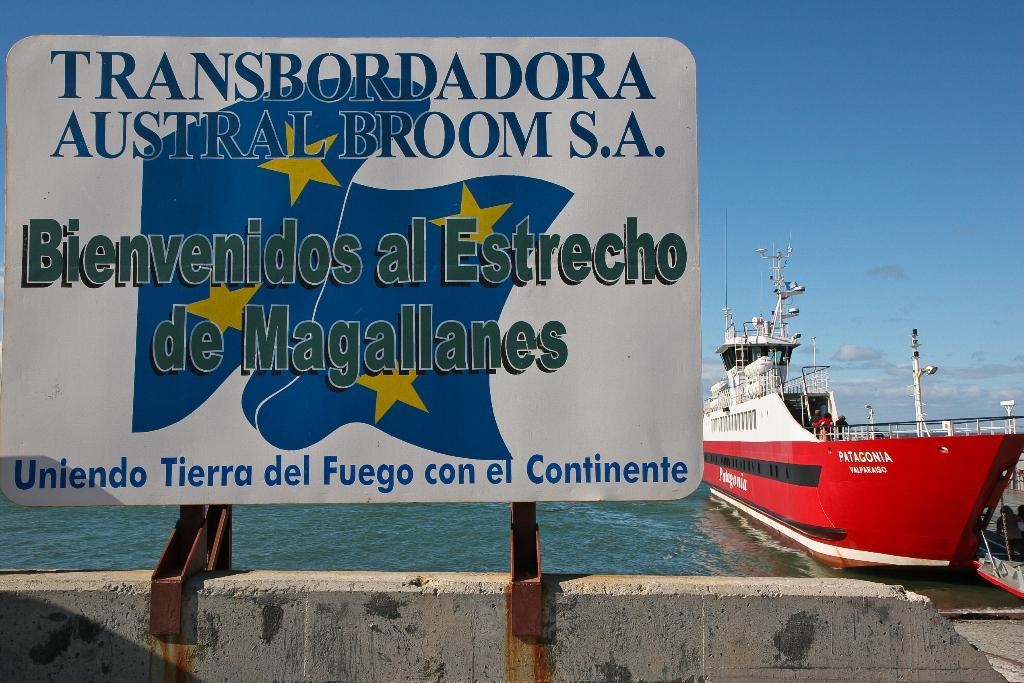What is located at the front of the image? There is a board in the front of the image. What can be seen on the board? There is text on the board. What can be seen in the background of the image? There is water and a ship visible in the background of the image. What is visible at the top of the image? The sky is visible at the top of the image. What type of orange tree can be seen growing on the ship in the image? There is no orange tree or any orange-related objects present in the image. 